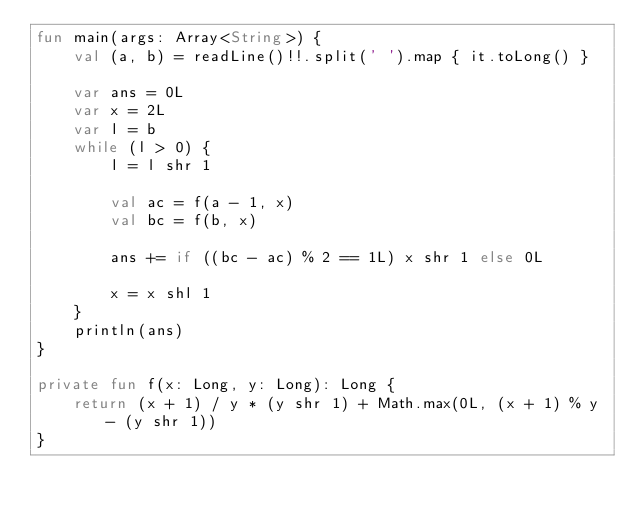<code> <loc_0><loc_0><loc_500><loc_500><_Kotlin_>fun main(args: Array<String>) {
    val (a, b) = readLine()!!.split(' ').map { it.toLong() }

    var ans = 0L
    var x = 2L
    var l = b
    while (l > 0) {
        l = l shr 1

        val ac = f(a - 1, x)
        val bc = f(b, x)

        ans += if ((bc - ac) % 2 == 1L) x shr 1 else 0L

        x = x shl 1
    }
    println(ans)
}

private fun f(x: Long, y: Long): Long {
    return (x + 1) / y * (y shr 1) + Math.max(0L, (x + 1) % y - (y shr 1))
}
</code> 